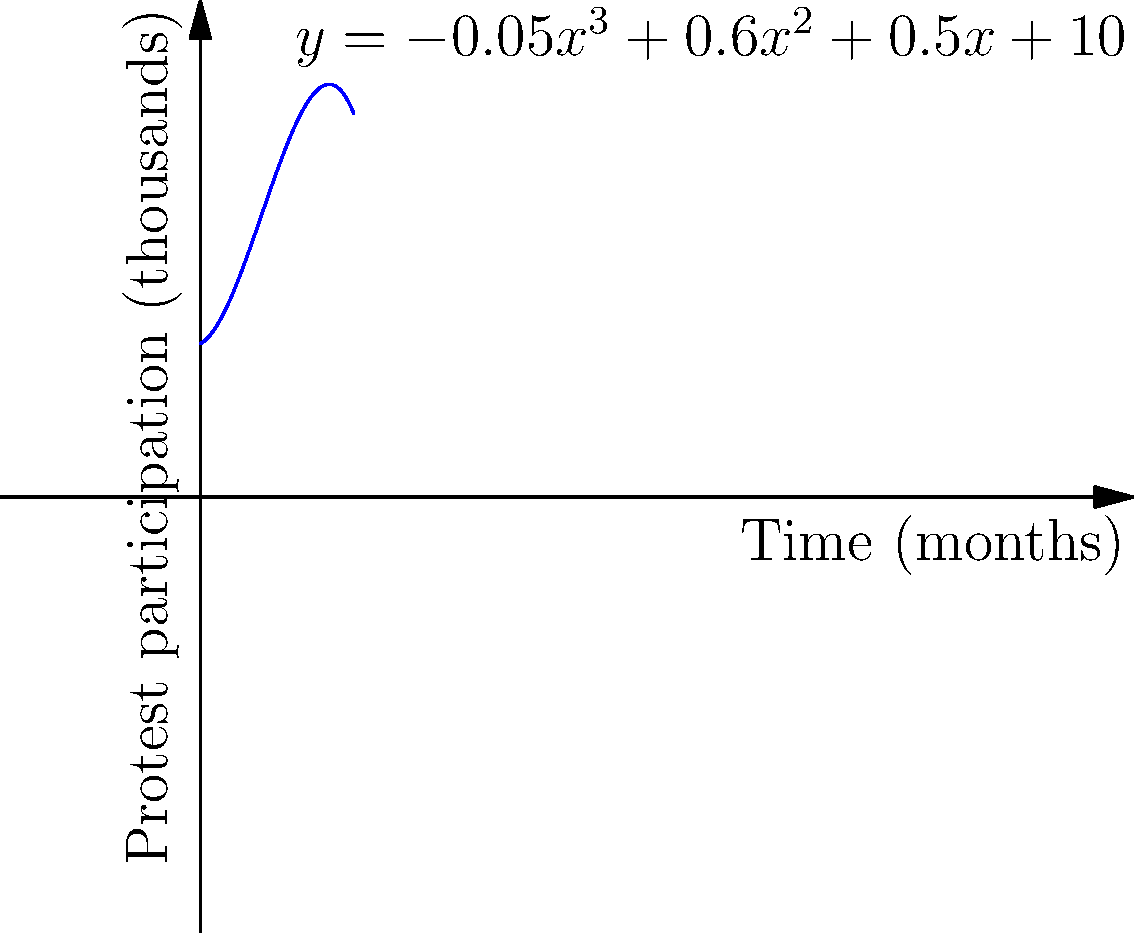The graph shows the trajectory of protest participation over time in thousands, modeled by the cubic polynomial $y = -0.05x^3 + 0.6x^2 + 0.5x + 10$, where $x$ represents months since the start of the movement. At what point in time does the protest participation reach its peak? Round your answer to the nearest month. To find the peak of the protest participation, we need to follow these steps:

1) The peak occurs at the maximum point of the function, which is where the derivative equals zero.

2) Let's find the derivative of $y = -0.05x^3 + 0.6x^2 + 0.5x + 10$:
   $y' = -0.15x^2 + 1.2x + 0.5$

3) Set the derivative to zero and solve for x:
   $-0.15x^2 + 1.2x + 0.5 = 0$

4) This is a quadratic equation. We can solve it using the quadratic formula:
   $x = \frac{-b \pm \sqrt{b^2 - 4ac}}{2a}$

   Where $a = -0.15$, $b = 1.2$, and $c = 0.5$

5) Plugging in these values:
   $x = \frac{-1.2 \pm \sqrt{1.2^2 - 4(-0.15)(0.5)}}{2(-0.15)}$

6) Simplifying:
   $x = \frac{-1.2 \pm \sqrt{1.44 + 0.3}}{-0.3} = \frac{-1.2 \pm \sqrt{1.74}}{-0.3}$

7) Calculating:
   $x \approx 5.37$ or $x \approx 2.63$

8) The larger value (5.37) corresponds to the maximum, as we can verify by checking the second derivative or by observing the graph.

9) Rounding to the nearest month: 5 months.
Answer: 5 months 